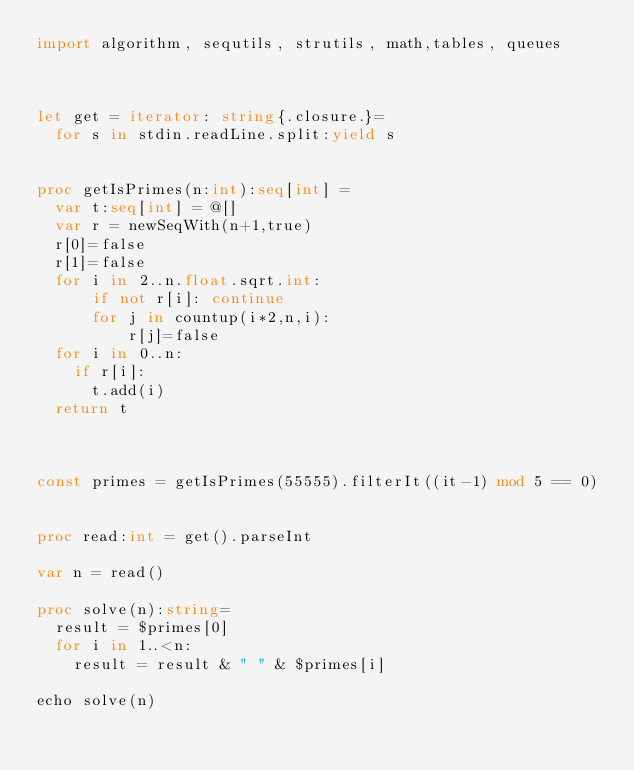<code> <loc_0><loc_0><loc_500><loc_500><_Nim_>import algorithm, sequtils, strutils, math,tables, queues



let get = iterator: string{.closure.}=
  for s in stdin.readLine.split:yield s
 
 
proc getIsPrimes(n:int):seq[int] = 
  var t:seq[int] = @[]
  var r = newSeqWith(n+1,true)
  r[0]=false
  r[1]=false
  for i in 2..n.float.sqrt.int:
      if not r[i]: continue
      for j in countup(i*2,n,i):
          r[j]=false
  for i in 0..n:
    if r[i]:
      t.add(i)
  return t



const primes = getIsPrimes(55555).filterIt((it-1) mod 5 == 0)


proc read:int = get().parseInt

var n = read()
  
proc solve(n):string=
  result = $primes[0]
  for i in 1..<n:
    result = result & " " & $primes[i]

echo solve(n)</code> 